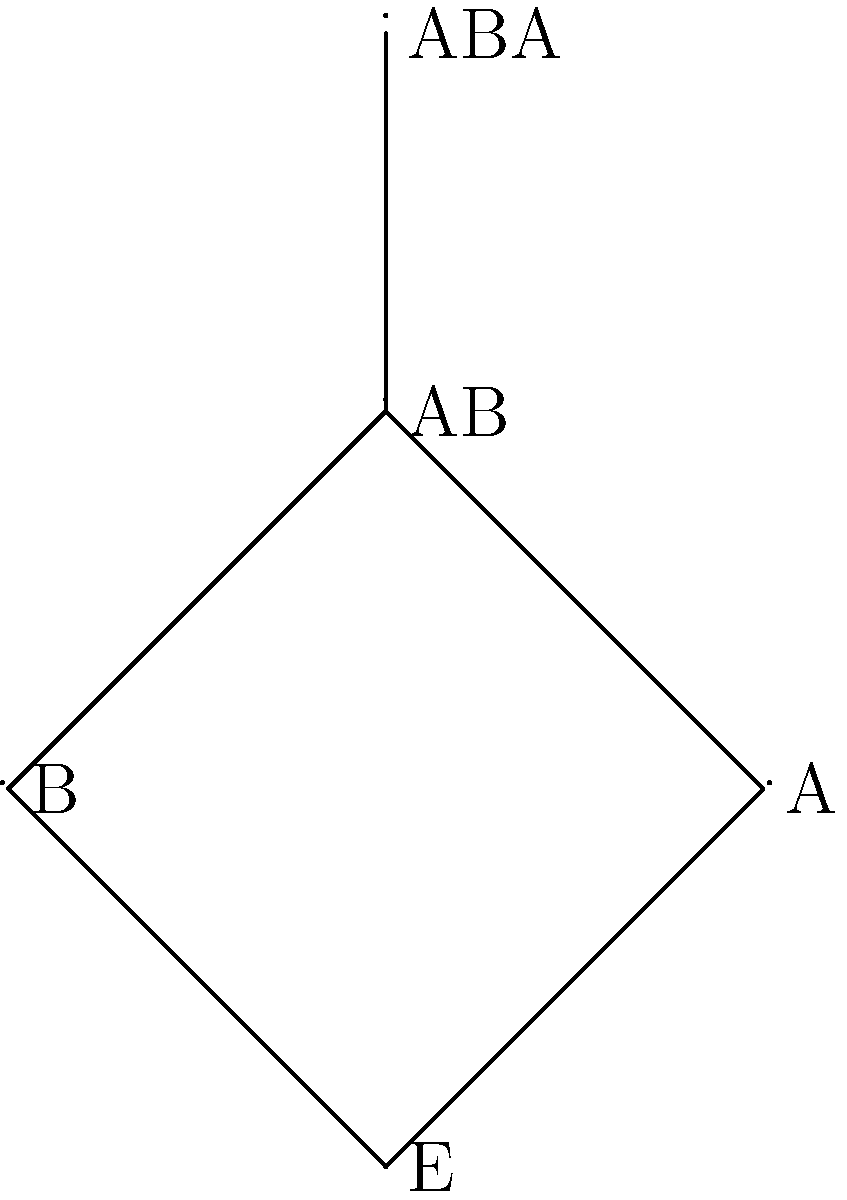In the lattice diagram above, representing combinations of skincare ingredients, E represents the empty set (no ingredients), A represents vitamin C, B represents hyaluronic acid, AB represents the combination of vitamin C and hyaluronic acid, and ABA represents a complex formulation with both ingredients plus additional stabilizers. Which of the following statements is true about the group structure of this skincare ingredient system?

a) The system forms a cyclic group
b) The system forms an abelian group
c) The system does not form a group
d) The system forms a non-abelian group To determine if this system forms a group and what type of group it might be, let's examine the properties:

1. Closure: The combination of any two elements should result in another element within the set. However, not all combinations are present (e.g., BA is missing), so closure is not satisfied.

2. Associativity: For the elements that can be combined, associativity would hold (e.g., (A * B) * A = A * (B * A) = ABA).

3. Identity element: E (empty set) could serve as the identity element, as combining it with any other element would not change that element.

4. Inverse elements: Not all elements have inverses within the set. For example, there's no element that, when combined with A, results in E.

Given these observations:

1. The system does not satisfy all group axioms, particularly closure and the existence of inverse elements for all members.
2. It cannot be a cyclic group or an abelian group, as it's not even a group.
3. The concept of being non-abelian doesn't apply, as the system is not a group.

Therefore, the correct answer is that this system does not form a group. The lattice diagram represents a partial ordering of skincare ingredient combinations rather than a group structure.
Answer: c) The system does not form a group 